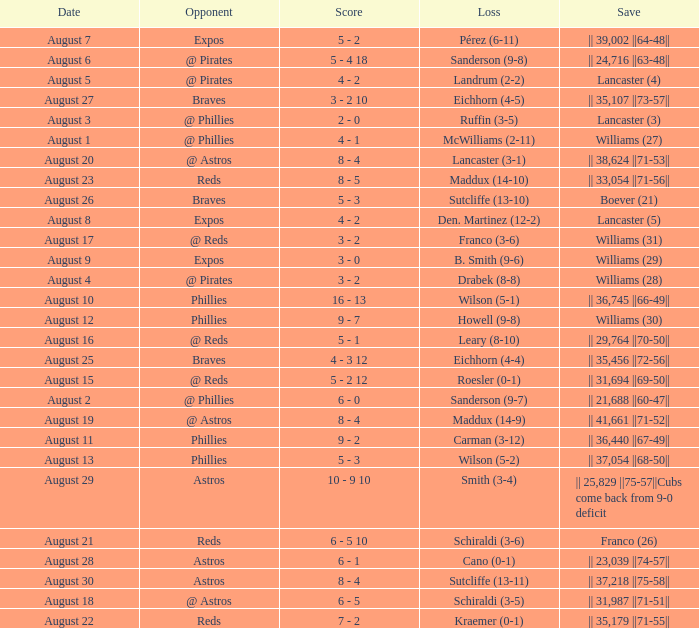Name the date with loss of carman (3-12) August 11. 